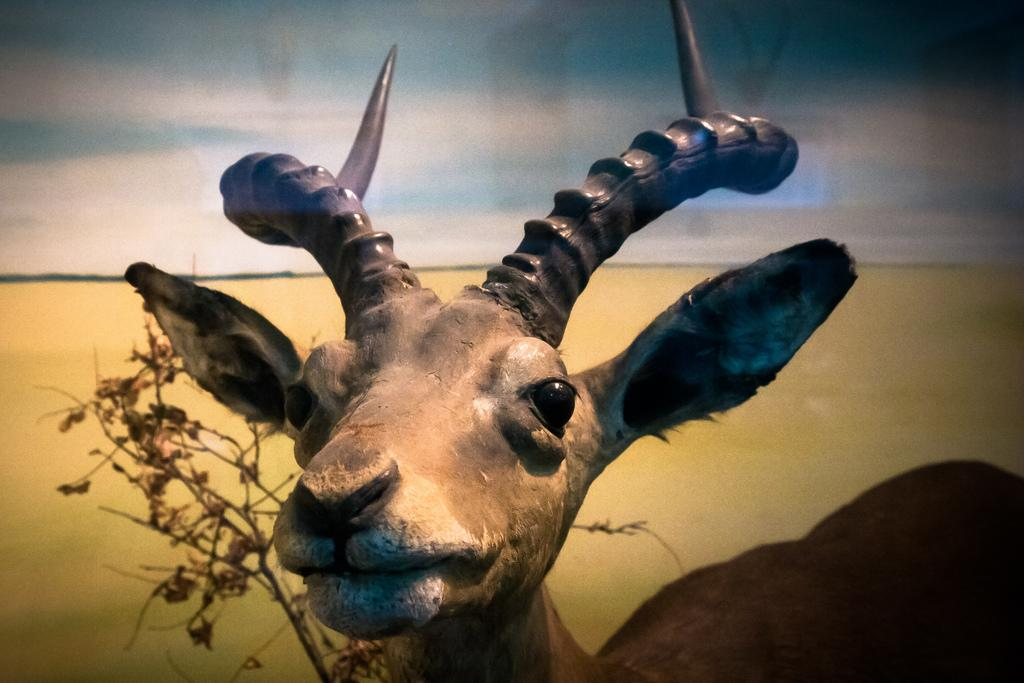What type of animal is present in the image? There is a deer in the image. What other object can be seen in the image? There is a dried plant in the image. What is the surface visible in the background of the image? There is a sand surface visible in the background of the image. What type of quilt is being used to cover the deer in the image? There is no quilt present in the image; the deer is not covered by any fabric. 